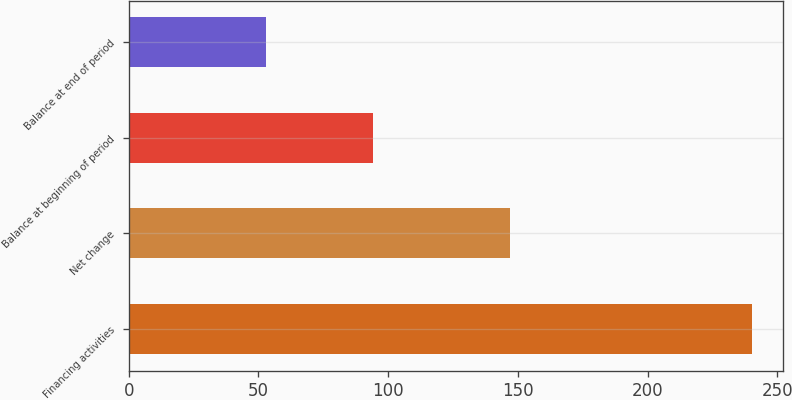<chart> <loc_0><loc_0><loc_500><loc_500><bar_chart><fcel>Financing activities<fcel>Net change<fcel>Balance at beginning of period<fcel>Balance at end of period<nl><fcel>240<fcel>147<fcel>94<fcel>53<nl></chart> 